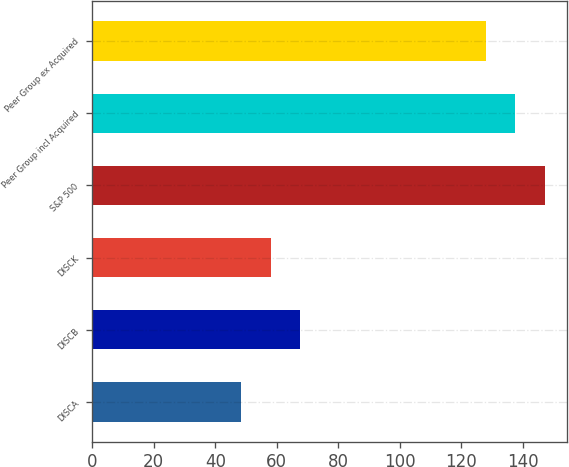<chart> <loc_0><loc_0><loc_500><loc_500><bar_chart><fcel>DISCA<fcel>DISCB<fcel>DISCK<fcel>S&P 500<fcel>Peer Group incl Acquired<fcel>Peer Group ex Acquired<nl><fcel>48.45<fcel>67.69<fcel>58.07<fcel>147.14<fcel>137.52<fcel>127.9<nl></chart> 